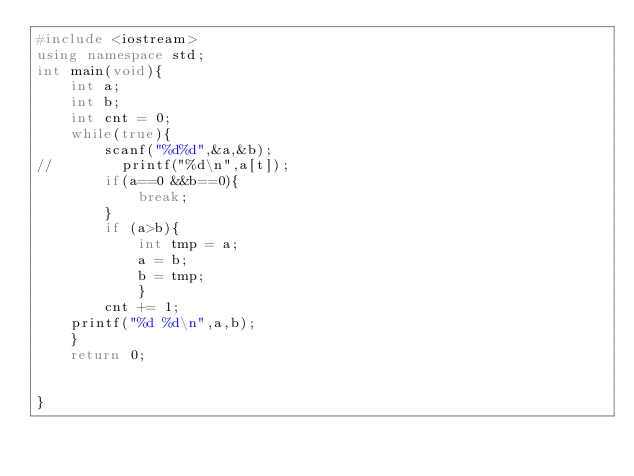Convert code to text. <code><loc_0><loc_0><loc_500><loc_500><_C++_>#include <iostream>
using namespace std;
int main(void){
    int a;
    int b;
    int cnt = 0;
    while(true){
        scanf("%d%d",&a,&b);
//        printf("%d\n",a[t]);
        if(a==0 &&b==0){
            break;
        }
        if (a>b){
            int tmp = a;
            a = b;
            b = tmp;
            }
        cnt += 1;
    printf("%d %d\n",a,b);
    }
    return 0;
    
    
}</code> 